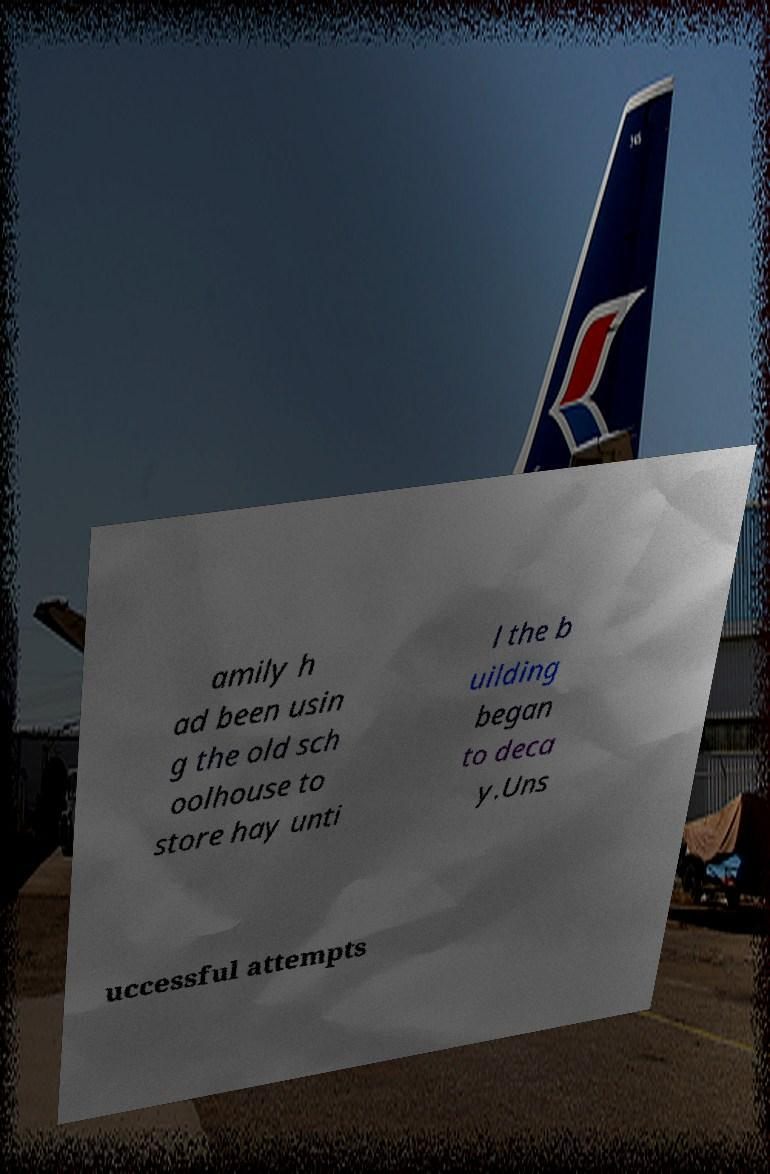What messages or text are displayed in this image? I need them in a readable, typed format. amily h ad been usin g the old sch oolhouse to store hay unti l the b uilding began to deca y.Uns uccessful attempts 